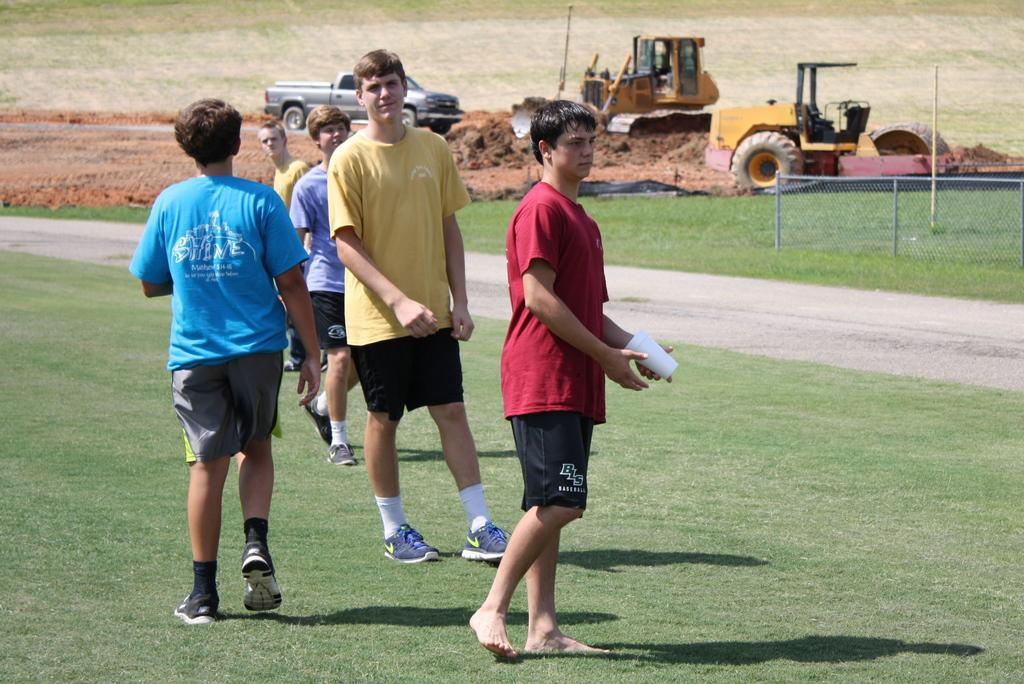What are the people in the image doing? The people in the image are standing on the ground. Can you describe the object being held by one of the people? One person is holding an object, but the specific object is not clear from the image. What can be seen in the background of the image? In the background of the image, there are vehicles, sand, poles, and a fence. Can you hear the quill being pulled in the image? There is no quill present in the image, and therefore it cannot be heard or pulled. 